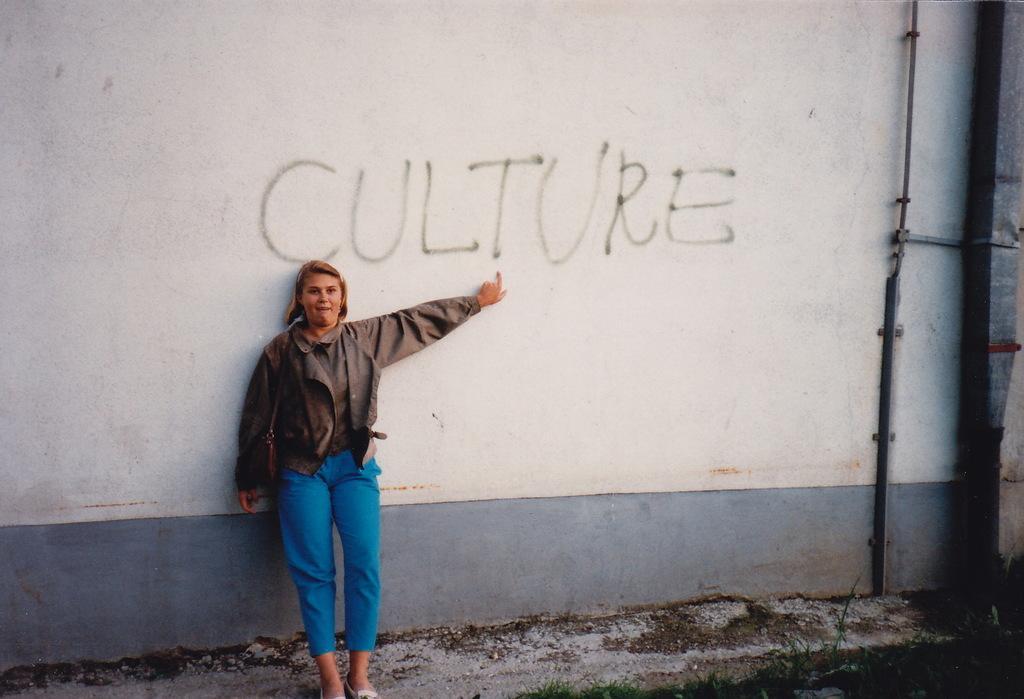Please provide a concise description of this image. In this image I can see a woman standing and leaning to the wall. She is smiling and pointing out the text which is on the wall. At the bottom, I can see the grass on the ground. On the right side there are two metal poles attached to the wall. 